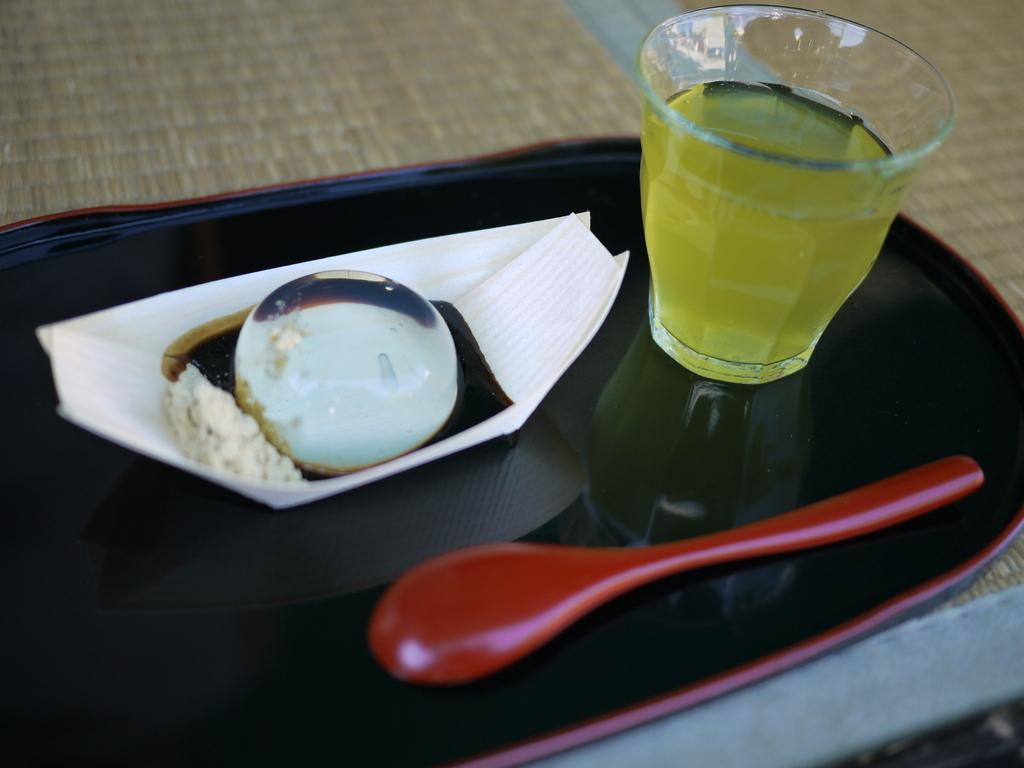What object is present in the image that can be used for eating or serving food? There is a tray in the image that can be used for eating or serving food. What items are on the tray in the image? The tray contains a spoon, tissue paper, and a ball. What type of beverage is in the glass in the image? The information provided does not specify the type of drink in the glass. Where is the tray placed in the image? The tray is placed on a floor or a table in the image. What type of lead can be seen in the image? There is no lead present in the image. 